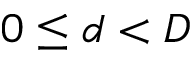<formula> <loc_0><loc_0><loc_500><loc_500>0 \leq d < D</formula> 